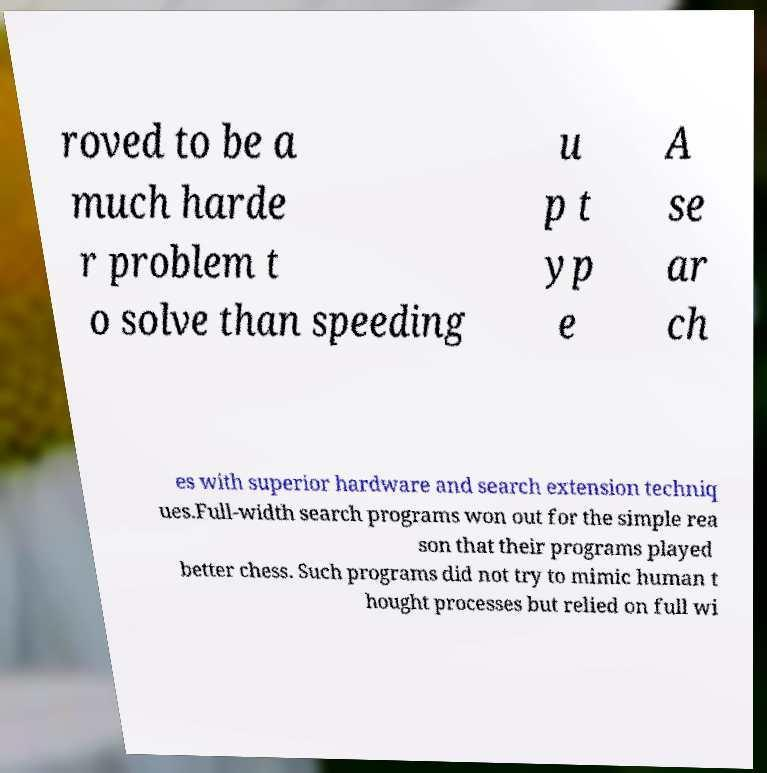Please identify and transcribe the text found in this image. roved to be a much harde r problem t o solve than speeding u p t yp e A se ar ch es with superior hardware and search extension techniq ues.Full-width search programs won out for the simple rea son that their programs played better chess. Such programs did not try to mimic human t hought processes but relied on full wi 